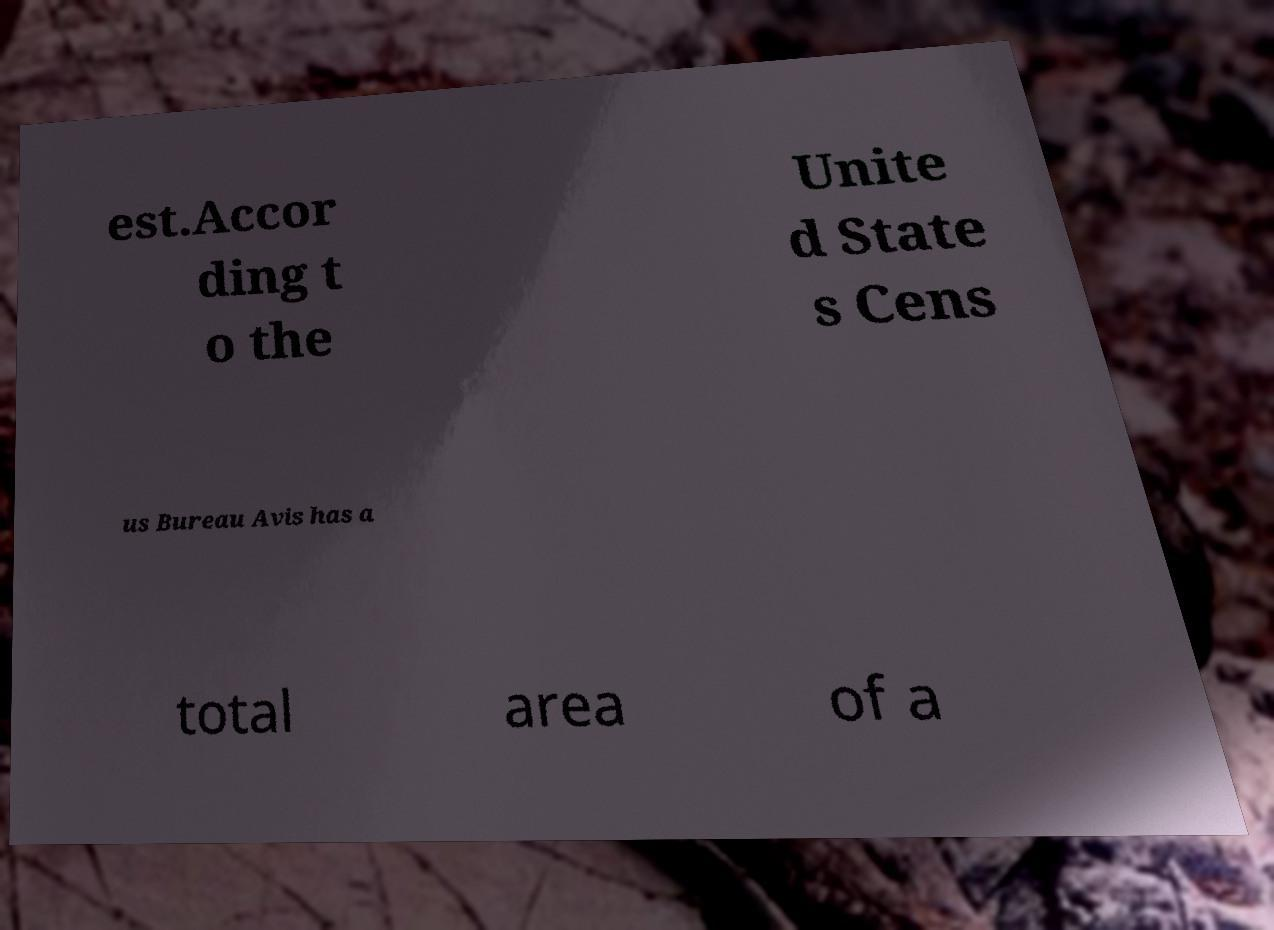There's text embedded in this image that I need extracted. Can you transcribe it verbatim? est.Accor ding t o the Unite d State s Cens us Bureau Avis has a total area of a 